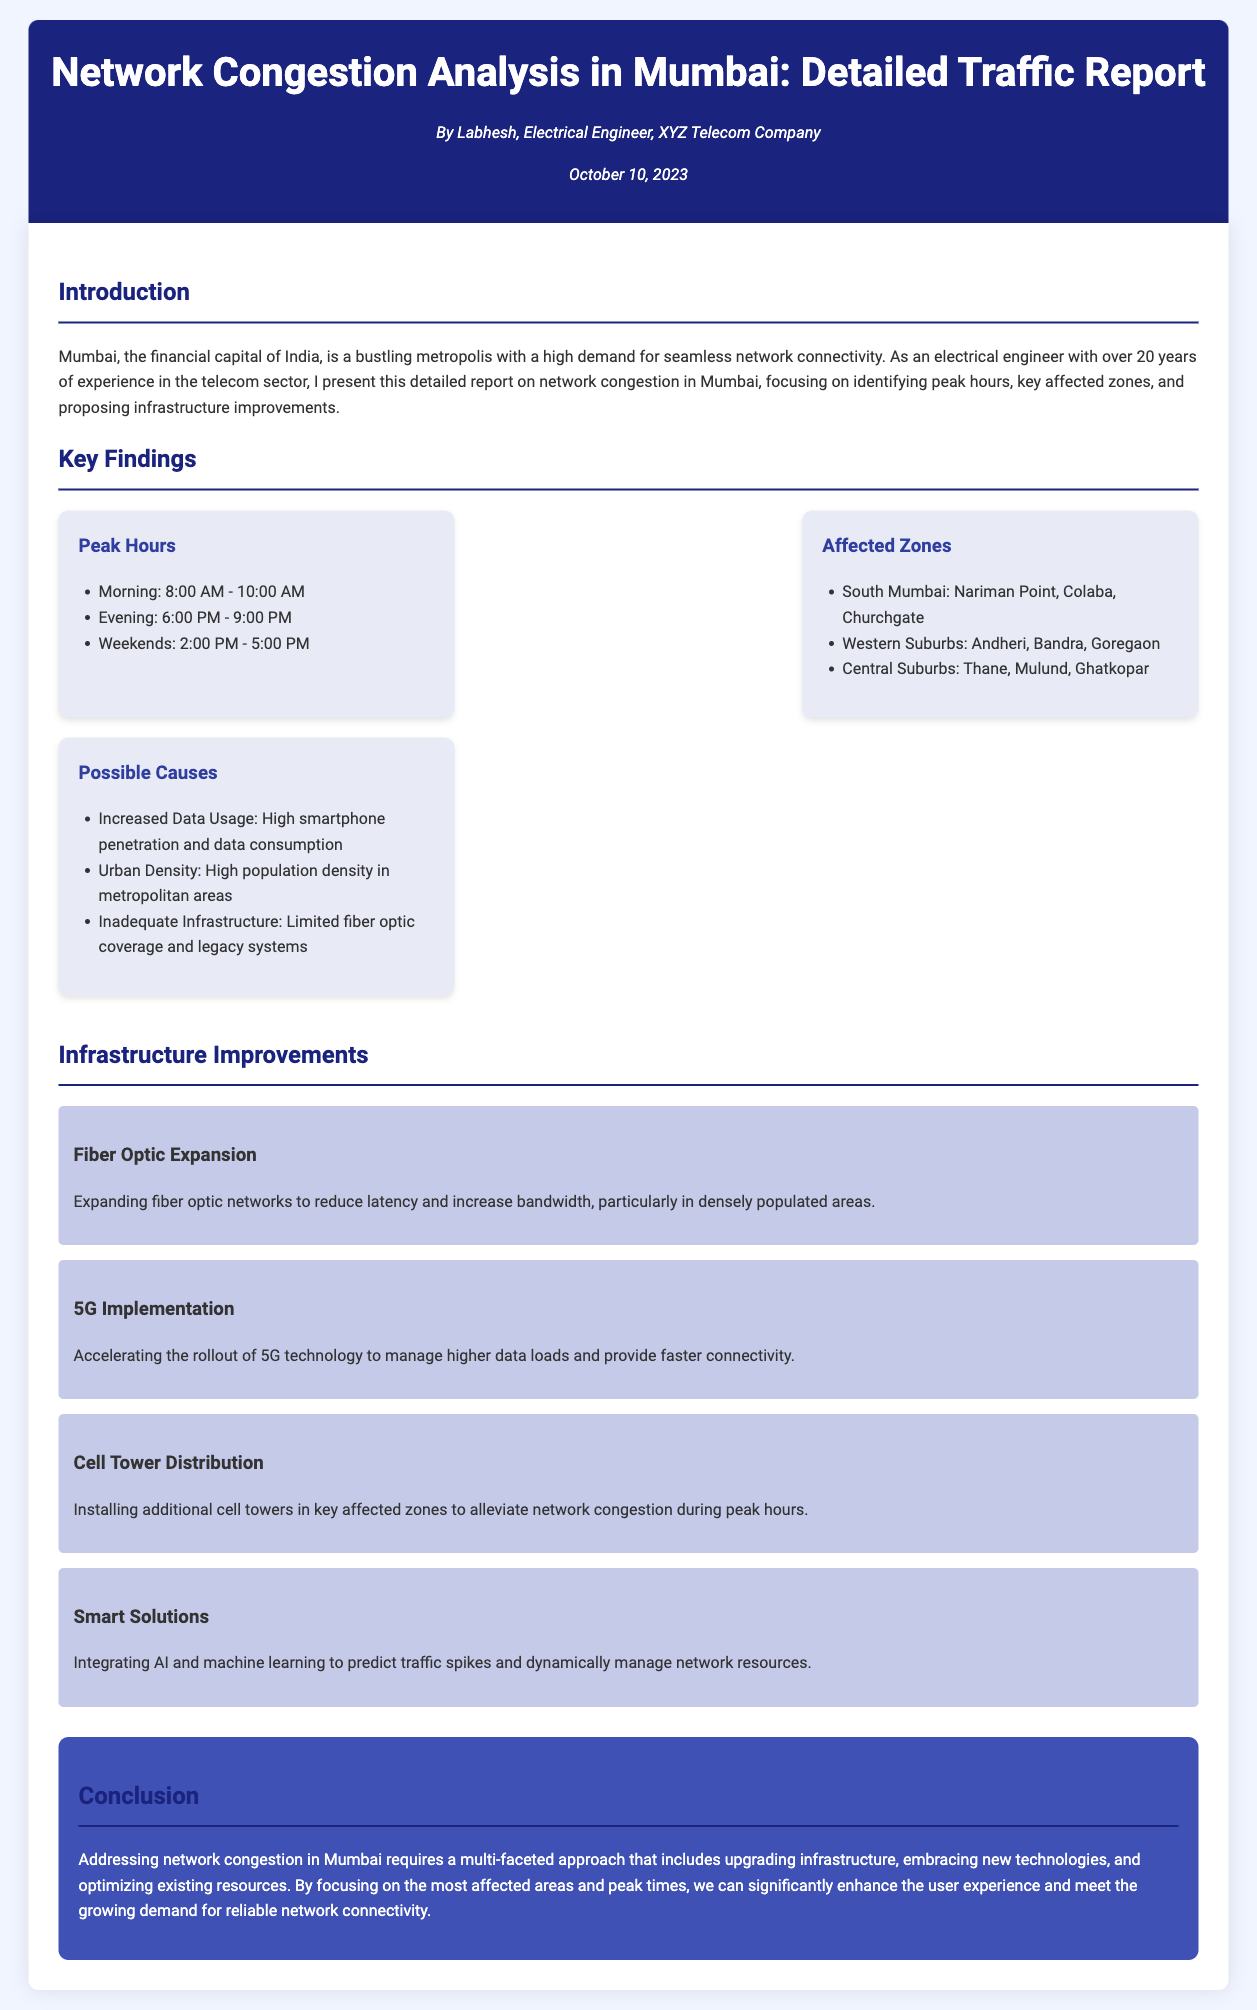What are the peak morning hours? The peak morning hours are listed as 8:00 AM - 10:00 AM in the findings section of the document.
Answer: 8:00 AM - 10:00 AM Which areas are affected during peak hours? The affected zones include specific locations in South Mumbai, Western Suburbs, and Central Suburbs as mentioned in the findings section.
Answer: South Mumbai, Western Suburbs, Central Suburbs What is one possible cause of network congestion? The document lists several causes, one of which is the increased data usage due to high smartphone penetration.
Answer: Increased Data Usage What improvement involves installing more infrastructure? The report suggests installing additional cell towers to alleviate network congestion, especially during peak hours.
Answer: Cell Tower Distribution What is the main focus of this report? The report’s main focus is on analyzing network congestion in Mumbai, particularly identifying peak hours and key affected zones.
Answer: Network Congestion in Mumbai When was this report published? The publication date of the document is indicated near the author's information.
Answer: October 10, 2023 What technological advancement is mentioned for data management? The report mentions integrating AI and machine learning as a smart solution for predicting traffic spikes.
Answer: AI and machine learning What is one proposed infrastructure improvement mentioned? The document lists fiber optic expansion as a proposed improvement to reduce latency and increase bandwidth.
Answer: Fiber Optic Expansion 